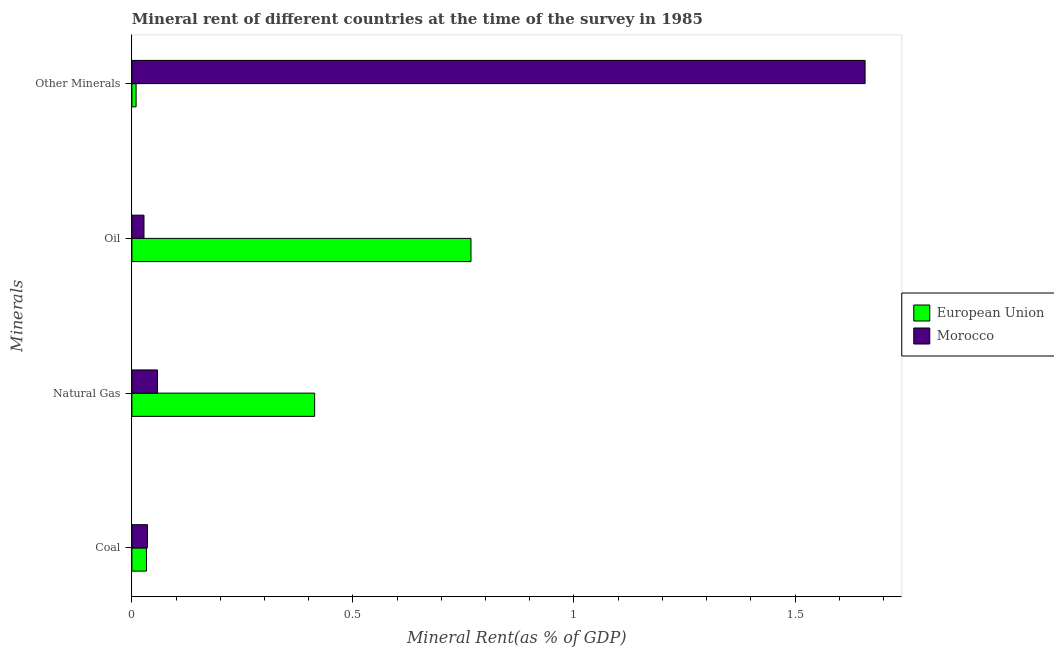How many different coloured bars are there?
Your answer should be very brief. 2. Are the number of bars per tick equal to the number of legend labels?
Ensure brevity in your answer.  Yes. Are the number of bars on each tick of the Y-axis equal?
Give a very brief answer. Yes. What is the label of the 2nd group of bars from the top?
Ensure brevity in your answer.  Oil. What is the oil rent in Morocco?
Give a very brief answer. 0.03. Across all countries, what is the maximum oil rent?
Offer a very short reply. 0.77. Across all countries, what is the minimum oil rent?
Give a very brief answer. 0.03. In which country was the coal rent maximum?
Your response must be concise. Morocco. What is the total natural gas rent in the graph?
Your response must be concise. 0.47. What is the difference between the  rent of other minerals in European Union and that in Morocco?
Keep it short and to the point. -1.65. What is the difference between the  rent of other minerals in European Union and the coal rent in Morocco?
Keep it short and to the point. -0.03. What is the average coal rent per country?
Keep it short and to the point. 0.03. What is the difference between the  rent of other minerals and coal rent in European Union?
Your answer should be compact. -0.02. What is the ratio of the coal rent in European Union to that in Morocco?
Offer a terse response. 0.94. Is the coal rent in Morocco less than that in European Union?
Provide a short and direct response. No. What is the difference between the highest and the second highest coal rent?
Your answer should be compact. 0. What is the difference between the highest and the lowest  rent of other minerals?
Keep it short and to the point. 1.65. In how many countries, is the coal rent greater than the average coal rent taken over all countries?
Provide a succinct answer. 1. Is it the case that in every country, the sum of the oil rent and natural gas rent is greater than the sum of coal rent and  rent of other minerals?
Your answer should be compact. Yes. What does the 1st bar from the top in Coal represents?
Offer a terse response. Morocco. What does the 2nd bar from the bottom in Oil represents?
Offer a terse response. Morocco. Is it the case that in every country, the sum of the coal rent and natural gas rent is greater than the oil rent?
Ensure brevity in your answer.  No. How many countries are there in the graph?
Offer a terse response. 2. What is the difference between two consecutive major ticks on the X-axis?
Provide a short and direct response. 0.5. Does the graph contain any zero values?
Ensure brevity in your answer.  No. How many legend labels are there?
Provide a succinct answer. 2. What is the title of the graph?
Give a very brief answer. Mineral rent of different countries at the time of the survey in 1985. What is the label or title of the X-axis?
Ensure brevity in your answer.  Mineral Rent(as % of GDP). What is the label or title of the Y-axis?
Your answer should be compact. Minerals. What is the Mineral Rent(as % of GDP) in European Union in Coal?
Give a very brief answer. 0.03. What is the Mineral Rent(as % of GDP) in Morocco in Coal?
Your answer should be compact. 0.04. What is the Mineral Rent(as % of GDP) of European Union in Natural Gas?
Make the answer very short. 0.41. What is the Mineral Rent(as % of GDP) in Morocco in Natural Gas?
Make the answer very short. 0.06. What is the Mineral Rent(as % of GDP) in European Union in Oil?
Your answer should be very brief. 0.77. What is the Mineral Rent(as % of GDP) of Morocco in Oil?
Offer a very short reply. 0.03. What is the Mineral Rent(as % of GDP) in European Union in Other Minerals?
Give a very brief answer. 0.01. What is the Mineral Rent(as % of GDP) in Morocco in Other Minerals?
Ensure brevity in your answer.  1.66. Across all Minerals, what is the maximum Mineral Rent(as % of GDP) of European Union?
Your answer should be very brief. 0.77. Across all Minerals, what is the maximum Mineral Rent(as % of GDP) of Morocco?
Make the answer very short. 1.66. Across all Minerals, what is the minimum Mineral Rent(as % of GDP) in European Union?
Your answer should be very brief. 0.01. Across all Minerals, what is the minimum Mineral Rent(as % of GDP) of Morocco?
Provide a succinct answer. 0.03. What is the total Mineral Rent(as % of GDP) of European Union in the graph?
Give a very brief answer. 1.22. What is the total Mineral Rent(as % of GDP) in Morocco in the graph?
Your answer should be compact. 1.78. What is the difference between the Mineral Rent(as % of GDP) of European Union in Coal and that in Natural Gas?
Your response must be concise. -0.38. What is the difference between the Mineral Rent(as % of GDP) of Morocco in Coal and that in Natural Gas?
Give a very brief answer. -0.02. What is the difference between the Mineral Rent(as % of GDP) of European Union in Coal and that in Oil?
Ensure brevity in your answer.  -0.73. What is the difference between the Mineral Rent(as % of GDP) in Morocco in Coal and that in Oil?
Give a very brief answer. 0.01. What is the difference between the Mineral Rent(as % of GDP) of European Union in Coal and that in Other Minerals?
Ensure brevity in your answer.  0.02. What is the difference between the Mineral Rent(as % of GDP) of Morocco in Coal and that in Other Minerals?
Provide a succinct answer. -1.62. What is the difference between the Mineral Rent(as % of GDP) of European Union in Natural Gas and that in Oil?
Your answer should be very brief. -0.35. What is the difference between the Mineral Rent(as % of GDP) of Morocco in Natural Gas and that in Oil?
Offer a very short reply. 0.03. What is the difference between the Mineral Rent(as % of GDP) in European Union in Natural Gas and that in Other Minerals?
Ensure brevity in your answer.  0.4. What is the difference between the Mineral Rent(as % of GDP) in Morocco in Natural Gas and that in Other Minerals?
Your response must be concise. -1.6. What is the difference between the Mineral Rent(as % of GDP) in European Union in Oil and that in Other Minerals?
Provide a short and direct response. 0.76. What is the difference between the Mineral Rent(as % of GDP) of Morocco in Oil and that in Other Minerals?
Provide a succinct answer. -1.63. What is the difference between the Mineral Rent(as % of GDP) in European Union in Coal and the Mineral Rent(as % of GDP) in Morocco in Natural Gas?
Your response must be concise. -0.03. What is the difference between the Mineral Rent(as % of GDP) in European Union in Coal and the Mineral Rent(as % of GDP) in Morocco in Oil?
Provide a short and direct response. 0.01. What is the difference between the Mineral Rent(as % of GDP) of European Union in Coal and the Mineral Rent(as % of GDP) of Morocco in Other Minerals?
Offer a very short reply. -1.63. What is the difference between the Mineral Rent(as % of GDP) in European Union in Natural Gas and the Mineral Rent(as % of GDP) in Morocco in Oil?
Make the answer very short. 0.39. What is the difference between the Mineral Rent(as % of GDP) of European Union in Natural Gas and the Mineral Rent(as % of GDP) of Morocco in Other Minerals?
Ensure brevity in your answer.  -1.25. What is the difference between the Mineral Rent(as % of GDP) in European Union in Oil and the Mineral Rent(as % of GDP) in Morocco in Other Minerals?
Offer a very short reply. -0.89. What is the average Mineral Rent(as % of GDP) in European Union per Minerals?
Keep it short and to the point. 0.31. What is the average Mineral Rent(as % of GDP) in Morocco per Minerals?
Offer a terse response. 0.44. What is the difference between the Mineral Rent(as % of GDP) in European Union and Mineral Rent(as % of GDP) in Morocco in Coal?
Your answer should be compact. -0. What is the difference between the Mineral Rent(as % of GDP) in European Union and Mineral Rent(as % of GDP) in Morocco in Natural Gas?
Keep it short and to the point. 0.36. What is the difference between the Mineral Rent(as % of GDP) of European Union and Mineral Rent(as % of GDP) of Morocco in Oil?
Provide a short and direct response. 0.74. What is the difference between the Mineral Rent(as % of GDP) of European Union and Mineral Rent(as % of GDP) of Morocco in Other Minerals?
Keep it short and to the point. -1.65. What is the ratio of the Mineral Rent(as % of GDP) in European Union in Coal to that in Natural Gas?
Provide a short and direct response. 0.08. What is the ratio of the Mineral Rent(as % of GDP) in Morocco in Coal to that in Natural Gas?
Your answer should be compact. 0.61. What is the ratio of the Mineral Rent(as % of GDP) of European Union in Coal to that in Oil?
Offer a terse response. 0.04. What is the ratio of the Mineral Rent(as % of GDP) of Morocco in Coal to that in Oil?
Your answer should be very brief. 1.29. What is the ratio of the Mineral Rent(as % of GDP) in European Union in Coal to that in Other Minerals?
Make the answer very short. 3.44. What is the ratio of the Mineral Rent(as % of GDP) of Morocco in Coal to that in Other Minerals?
Give a very brief answer. 0.02. What is the ratio of the Mineral Rent(as % of GDP) of European Union in Natural Gas to that in Oil?
Provide a succinct answer. 0.54. What is the ratio of the Mineral Rent(as % of GDP) in Morocco in Natural Gas to that in Oil?
Give a very brief answer. 2.12. What is the ratio of the Mineral Rent(as % of GDP) of European Union in Natural Gas to that in Other Minerals?
Your answer should be very brief. 43.14. What is the ratio of the Mineral Rent(as % of GDP) in Morocco in Natural Gas to that in Other Minerals?
Your response must be concise. 0.03. What is the ratio of the Mineral Rent(as % of GDP) in European Union in Oil to that in Other Minerals?
Provide a succinct answer. 80.05. What is the ratio of the Mineral Rent(as % of GDP) in Morocco in Oil to that in Other Minerals?
Give a very brief answer. 0.02. What is the difference between the highest and the second highest Mineral Rent(as % of GDP) in European Union?
Your answer should be very brief. 0.35. What is the difference between the highest and the second highest Mineral Rent(as % of GDP) of Morocco?
Provide a succinct answer. 1.6. What is the difference between the highest and the lowest Mineral Rent(as % of GDP) of European Union?
Your response must be concise. 0.76. What is the difference between the highest and the lowest Mineral Rent(as % of GDP) of Morocco?
Your answer should be compact. 1.63. 